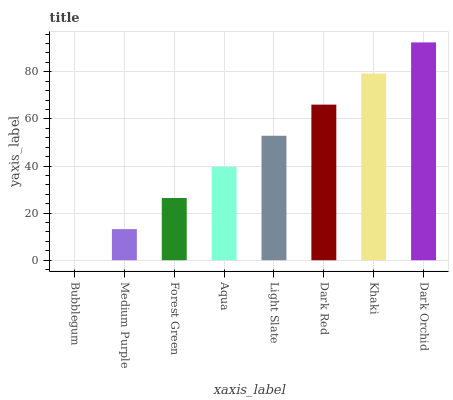Is Bubblegum the minimum?
Answer yes or no. Yes. Is Dark Orchid the maximum?
Answer yes or no. Yes. Is Medium Purple the minimum?
Answer yes or no. No. Is Medium Purple the maximum?
Answer yes or no. No. Is Medium Purple greater than Bubblegum?
Answer yes or no. Yes. Is Bubblegum less than Medium Purple?
Answer yes or no. Yes. Is Bubblegum greater than Medium Purple?
Answer yes or no. No. Is Medium Purple less than Bubblegum?
Answer yes or no. No. Is Light Slate the high median?
Answer yes or no. Yes. Is Aqua the low median?
Answer yes or no. Yes. Is Medium Purple the high median?
Answer yes or no. No. Is Forest Green the low median?
Answer yes or no. No. 